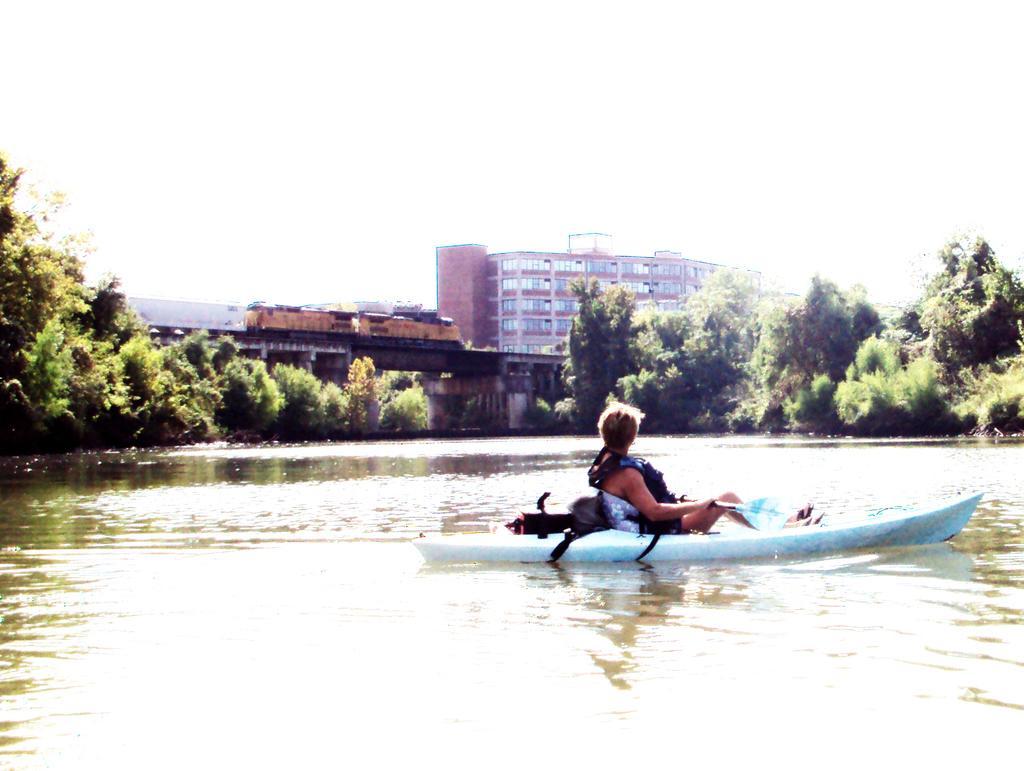Describe this image in one or two sentences. In this image there is the sky towards the top of the image, there is a building, there is a bridge, there is a train on the bridge, there are trees towards the right of the image, there are trees towards the left of the image, there is water towards the bottom of the image, there is a boat on the water, there is a woman sitting on the boat, she is holding an object. 